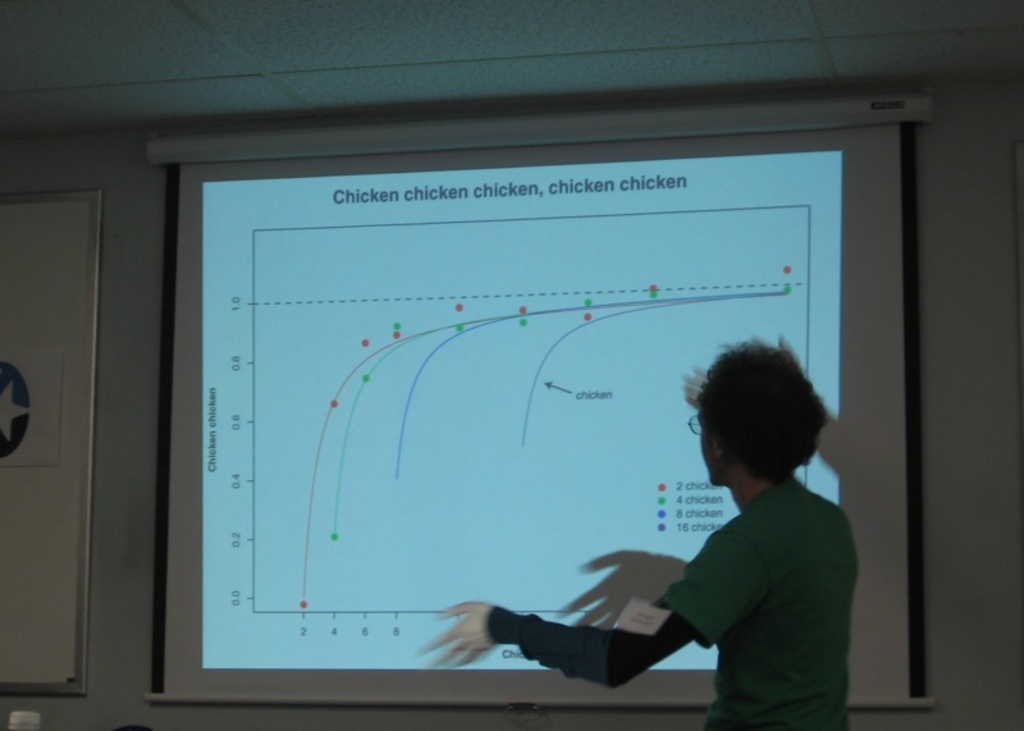Provide a one-sentence caption for the provided image. A person enthusiastically presents a humorous chart with repeated mentions of 'chicken', sparking intrigue and laughter about the data's peculiar presentation. 